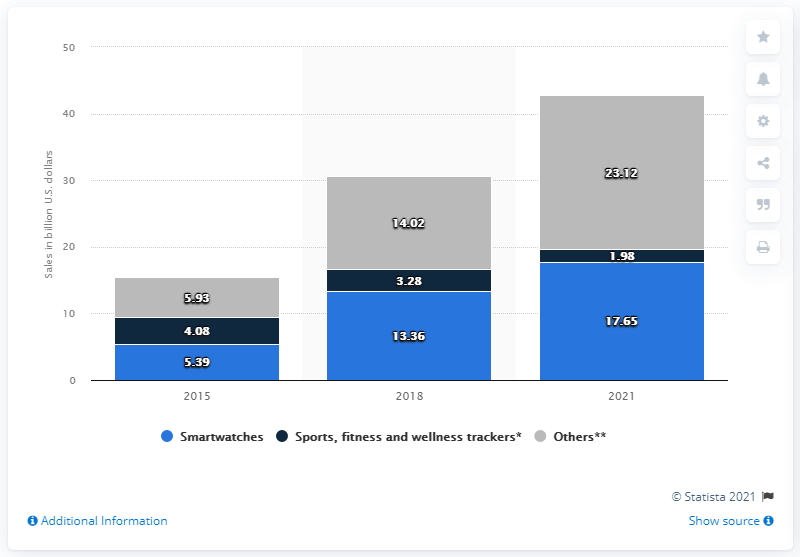Highlight a few significant elements in this photo. In 2018, the product line that generated the most revenue is X, with Y other products bringing in revenue as well. The sales of wearables worldwide are expected to end in 2021. In 2015, smartwatch revenue was 12.26 million, while in 2021 it increased to X million. In 2015, the global revenue from smartwatch sales was 5.39 billion U.S. dollars. 